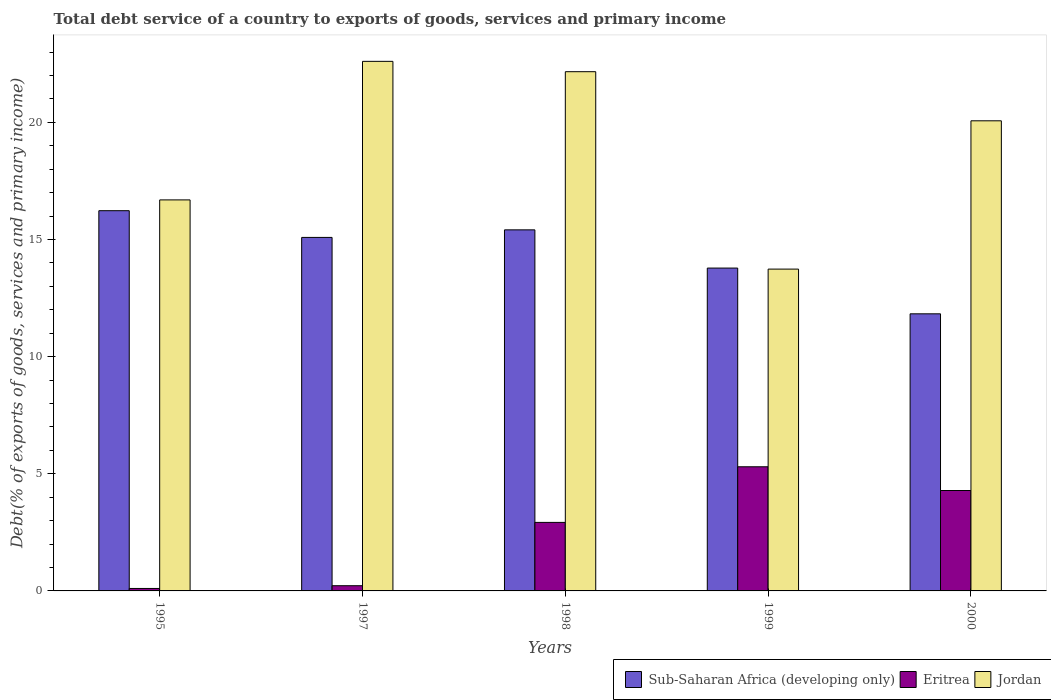How many different coloured bars are there?
Keep it short and to the point. 3. How many groups of bars are there?
Make the answer very short. 5. Are the number of bars per tick equal to the number of legend labels?
Make the answer very short. Yes. How many bars are there on the 5th tick from the left?
Give a very brief answer. 3. How many bars are there on the 2nd tick from the right?
Offer a terse response. 3. What is the label of the 4th group of bars from the left?
Make the answer very short. 1999. In how many cases, is the number of bars for a given year not equal to the number of legend labels?
Your response must be concise. 0. What is the total debt service in Jordan in 1997?
Keep it short and to the point. 22.6. Across all years, what is the maximum total debt service in Sub-Saharan Africa (developing only)?
Ensure brevity in your answer.  16.23. Across all years, what is the minimum total debt service in Sub-Saharan Africa (developing only)?
Give a very brief answer. 11.83. What is the total total debt service in Jordan in the graph?
Give a very brief answer. 95.25. What is the difference between the total debt service in Sub-Saharan Africa (developing only) in 1998 and that in 1999?
Give a very brief answer. 1.63. What is the difference between the total debt service in Eritrea in 2000 and the total debt service in Jordan in 1995?
Make the answer very short. -12.4. What is the average total debt service in Jordan per year?
Keep it short and to the point. 19.05. In the year 1998, what is the difference between the total debt service in Jordan and total debt service in Sub-Saharan Africa (developing only)?
Provide a short and direct response. 6.75. What is the ratio of the total debt service in Sub-Saharan Africa (developing only) in 1997 to that in 2000?
Make the answer very short. 1.28. Is the total debt service in Jordan in 1997 less than that in 2000?
Give a very brief answer. No. What is the difference between the highest and the second highest total debt service in Sub-Saharan Africa (developing only)?
Your response must be concise. 0.82. What is the difference between the highest and the lowest total debt service in Eritrea?
Your response must be concise. 5.19. What does the 1st bar from the left in 1995 represents?
Offer a very short reply. Sub-Saharan Africa (developing only). What does the 1st bar from the right in 1999 represents?
Your answer should be compact. Jordan. Is it the case that in every year, the sum of the total debt service in Eritrea and total debt service in Sub-Saharan Africa (developing only) is greater than the total debt service in Jordan?
Your response must be concise. No. How many years are there in the graph?
Your answer should be compact. 5. Are the values on the major ticks of Y-axis written in scientific E-notation?
Make the answer very short. No. How many legend labels are there?
Your answer should be compact. 3. How are the legend labels stacked?
Give a very brief answer. Horizontal. What is the title of the graph?
Give a very brief answer. Total debt service of a country to exports of goods, services and primary income. What is the label or title of the X-axis?
Provide a short and direct response. Years. What is the label or title of the Y-axis?
Provide a succinct answer. Debt(% of exports of goods, services and primary income). What is the Debt(% of exports of goods, services and primary income) of Sub-Saharan Africa (developing only) in 1995?
Offer a terse response. 16.23. What is the Debt(% of exports of goods, services and primary income) of Eritrea in 1995?
Provide a succinct answer. 0.11. What is the Debt(% of exports of goods, services and primary income) in Jordan in 1995?
Give a very brief answer. 16.69. What is the Debt(% of exports of goods, services and primary income) of Sub-Saharan Africa (developing only) in 1997?
Provide a short and direct response. 15.09. What is the Debt(% of exports of goods, services and primary income) of Eritrea in 1997?
Offer a terse response. 0.22. What is the Debt(% of exports of goods, services and primary income) of Jordan in 1997?
Ensure brevity in your answer.  22.6. What is the Debt(% of exports of goods, services and primary income) in Sub-Saharan Africa (developing only) in 1998?
Provide a succinct answer. 15.41. What is the Debt(% of exports of goods, services and primary income) in Eritrea in 1998?
Your response must be concise. 2.92. What is the Debt(% of exports of goods, services and primary income) of Jordan in 1998?
Offer a very short reply. 22.16. What is the Debt(% of exports of goods, services and primary income) in Sub-Saharan Africa (developing only) in 1999?
Your answer should be very brief. 13.78. What is the Debt(% of exports of goods, services and primary income) in Eritrea in 1999?
Your answer should be very brief. 5.3. What is the Debt(% of exports of goods, services and primary income) in Jordan in 1999?
Your answer should be compact. 13.74. What is the Debt(% of exports of goods, services and primary income) in Sub-Saharan Africa (developing only) in 2000?
Give a very brief answer. 11.83. What is the Debt(% of exports of goods, services and primary income) of Eritrea in 2000?
Your answer should be very brief. 4.29. What is the Debt(% of exports of goods, services and primary income) in Jordan in 2000?
Keep it short and to the point. 20.07. Across all years, what is the maximum Debt(% of exports of goods, services and primary income) in Sub-Saharan Africa (developing only)?
Make the answer very short. 16.23. Across all years, what is the maximum Debt(% of exports of goods, services and primary income) in Eritrea?
Your answer should be compact. 5.3. Across all years, what is the maximum Debt(% of exports of goods, services and primary income) in Jordan?
Give a very brief answer. 22.6. Across all years, what is the minimum Debt(% of exports of goods, services and primary income) in Sub-Saharan Africa (developing only)?
Your answer should be very brief. 11.83. Across all years, what is the minimum Debt(% of exports of goods, services and primary income) of Eritrea?
Ensure brevity in your answer.  0.11. Across all years, what is the minimum Debt(% of exports of goods, services and primary income) in Jordan?
Your response must be concise. 13.74. What is the total Debt(% of exports of goods, services and primary income) of Sub-Saharan Africa (developing only) in the graph?
Ensure brevity in your answer.  72.33. What is the total Debt(% of exports of goods, services and primary income) of Eritrea in the graph?
Provide a short and direct response. 12.84. What is the total Debt(% of exports of goods, services and primary income) in Jordan in the graph?
Keep it short and to the point. 95.25. What is the difference between the Debt(% of exports of goods, services and primary income) of Sub-Saharan Africa (developing only) in 1995 and that in 1997?
Provide a short and direct response. 1.14. What is the difference between the Debt(% of exports of goods, services and primary income) of Eritrea in 1995 and that in 1997?
Your response must be concise. -0.12. What is the difference between the Debt(% of exports of goods, services and primary income) of Jordan in 1995 and that in 1997?
Provide a short and direct response. -5.91. What is the difference between the Debt(% of exports of goods, services and primary income) of Sub-Saharan Africa (developing only) in 1995 and that in 1998?
Ensure brevity in your answer.  0.82. What is the difference between the Debt(% of exports of goods, services and primary income) of Eritrea in 1995 and that in 1998?
Give a very brief answer. -2.82. What is the difference between the Debt(% of exports of goods, services and primary income) of Jordan in 1995 and that in 1998?
Offer a very short reply. -5.47. What is the difference between the Debt(% of exports of goods, services and primary income) in Sub-Saharan Africa (developing only) in 1995 and that in 1999?
Your answer should be compact. 2.45. What is the difference between the Debt(% of exports of goods, services and primary income) of Eritrea in 1995 and that in 1999?
Your answer should be compact. -5.19. What is the difference between the Debt(% of exports of goods, services and primary income) in Jordan in 1995 and that in 1999?
Make the answer very short. 2.95. What is the difference between the Debt(% of exports of goods, services and primary income) in Sub-Saharan Africa (developing only) in 1995 and that in 2000?
Offer a terse response. 4.4. What is the difference between the Debt(% of exports of goods, services and primary income) of Eritrea in 1995 and that in 2000?
Ensure brevity in your answer.  -4.18. What is the difference between the Debt(% of exports of goods, services and primary income) in Jordan in 1995 and that in 2000?
Your answer should be compact. -3.38. What is the difference between the Debt(% of exports of goods, services and primary income) in Sub-Saharan Africa (developing only) in 1997 and that in 1998?
Your answer should be compact. -0.32. What is the difference between the Debt(% of exports of goods, services and primary income) of Eritrea in 1997 and that in 1998?
Provide a succinct answer. -2.7. What is the difference between the Debt(% of exports of goods, services and primary income) in Jordan in 1997 and that in 1998?
Give a very brief answer. 0.44. What is the difference between the Debt(% of exports of goods, services and primary income) in Sub-Saharan Africa (developing only) in 1997 and that in 1999?
Your answer should be compact. 1.31. What is the difference between the Debt(% of exports of goods, services and primary income) of Eritrea in 1997 and that in 1999?
Your answer should be compact. -5.08. What is the difference between the Debt(% of exports of goods, services and primary income) in Jordan in 1997 and that in 1999?
Your answer should be very brief. 8.87. What is the difference between the Debt(% of exports of goods, services and primary income) of Sub-Saharan Africa (developing only) in 1997 and that in 2000?
Make the answer very short. 3.26. What is the difference between the Debt(% of exports of goods, services and primary income) of Eritrea in 1997 and that in 2000?
Keep it short and to the point. -4.06. What is the difference between the Debt(% of exports of goods, services and primary income) of Jordan in 1997 and that in 2000?
Your answer should be compact. 2.54. What is the difference between the Debt(% of exports of goods, services and primary income) in Sub-Saharan Africa (developing only) in 1998 and that in 1999?
Make the answer very short. 1.63. What is the difference between the Debt(% of exports of goods, services and primary income) of Eritrea in 1998 and that in 1999?
Provide a short and direct response. -2.37. What is the difference between the Debt(% of exports of goods, services and primary income) of Jordan in 1998 and that in 1999?
Provide a succinct answer. 8.43. What is the difference between the Debt(% of exports of goods, services and primary income) in Sub-Saharan Africa (developing only) in 1998 and that in 2000?
Offer a terse response. 3.58. What is the difference between the Debt(% of exports of goods, services and primary income) in Eritrea in 1998 and that in 2000?
Make the answer very short. -1.36. What is the difference between the Debt(% of exports of goods, services and primary income) in Jordan in 1998 and that in 2000?
Keep it short and to the point. 2.1. What is the difference between the Debt(% of exports of goods, services and primary income) of Sub-Saharan Africa (developing only) in 1999 and that in 2000?
Your answer should be compact. 1.95. What is the difference between the Debt(% of exports of goods, services and primary income) in Eritrea in 1999 and that in 2000?
Your response must be concise. 1.01. What is the difference between the Debt(% of exports of goods, services and primary income) in Jordan in 1999 and that in 2000?
Ensure brevity in your answer.  -6.33. What is the difference between the Debt(% of exports of goods, services and primary income) of Sub-Saharan Africa (developing only) in 1995 and the Debt(% of exports of goods, services and primary income) of Eritrea in 1997?
Your response must be concise. 16.01. What is the difference between the Debt(% of exports of goods, services and primary income) in Sub-Saharan Africa (developing only) in 1995 and the Debt(% of exports of goods, services and primary income) in Jordan in 1997?
Give a very brief answer. -6.37. What is the difference between the Debt(% of exports of goods, services and primary income) of Eritrea in 1995 and the Debt(% of exports of goods, services and primary income) of Jordan in 1997?
Offer a very short reply. -22.5. What is the difference between the Debt(% of exports of goods, services and primary income) of Sub-Saharan Africa (developing only) in 1995 and the Debt(% of exports of goods, services and primary income) of Eritrea in 1998?
Provide a short and direct response. 13.3. What is the difference between the Debt(% of exports of goods, services and primary income) of Sub-Saharan Africa (developing only) in 1995 and the Debt(% of exports of goods, services and primary income) of Jordan in 1998?
Provide a succinct answer. -5.93. What is the difference between the Debt(% of exports of goods, services and primary income) of Eritrea in 1995 and the Debt(% of exports of goods, services and primary income) of Jordan in 1998?
Keep it short and to the point. -22.06. What is the difference between the Debt(% of exports of goods, services and primary income) of Sub-Saharan Africa (developing only) in 1995 and the Debt(% of exports of goods, services and primary income) of Eritrea in 1999?
Your answer should be compact. 10.93. What is the difference between the Debt(% of exports of goods, services and primary income) in Sub-Saharan Africa (developing only) in 1995 and the Debt(% of exports of goods, services and primary income) in Jordan in 1999?
Your answer should be very brief. 2.49. What is the difference between the Debt(% of exports of goods, services and primary income) of Eritrea in 1995 and the Debt(% of exports of goods, services and primary income) of Jordan in 1999?
Provide a succinct answer. -13.63. What is the difference between the Debt(% of exports of goods, services and primary income) in Sub-Saharan Africa (developing only) in 1995 and the Debt(% of exports of goods, services and primary income) in Eritrea in 2000?
Ensure brevity in your answer.  11.94. What is the difference between the Debt(% of exports of goods, services and primary income) in Sub-Saharan Africa (developing only) in 1995 and the Debt(% of exports of goods, services and primary income) in Jordan in 2000?
Your answer should be very brief. -3.84. What is the difference between the Debt(% of exports of goods, services and primary income) in Eritrea in 1995 and the Debt(% of exports of goods, services and primary income) in Jordan in 2000?
Your answer should be very brief. -19.96. What is the difference between the Debt(% of exports of goods, services and primary income) of Sub-Saharan Africa (developing only) in 1997 and the Debt(% of exports of goods, services and primary income) of Eritrea in 1998?
Provide a succinct answer. 12.16. What is the difference between the Debt(% of exports of goods, services and primary income) in Sub-Saharan Africa (developing only) in 1997 and the Debt(% of exports of goods, services and primary income) in Jordan in 1998?
Your answer should be compact. -7.07. What is the difference between the Debt(% of exports of goods, services and primary income) of Eritrea in 1997 and the Debt(% of exports of goods, services and primary income) of Jordan in 1998?
Your response must be concise. -21.94. What is the difference between the Debt(% of exports of goods, services and primary income) in Sub-Saharan Africa (developing only) in 1997 and the Debt(% of exports of goods, services and primary income) in Eritrea in 1999?
Your answer should be very brief. 9.79. What is the difference between the Debt(% of exports of goods, services and primary income) of Sub-Saharan Africa (developing only) in 1997 and the Debt(% of exports of goods, services and primary income) of Jordan in 1999?
Ensure brevity in your answer.  1.35. What is the difference between the Debt(% of exports of goods, services and primary income) of Eritrea in 1997 and the Debt(% of exports of goods, services and primary income) of Jordan in 1999?
Provide a short and direct response. -13.51. What is the difference between the Debt(% of exports of goods, services and primary income) in Sub-Saharan Africa (developing only) in 1997 and the Debt(% of exports of goods, services and primary income) in Eritrea in 2000?
Offer a terse response. 10.8. What is the difference between the Debt(% of exports of goods, services and primary income) in Sub-Saharan Africa (developing only) in 1997 and the Debt(% of exports of goods, services and primary income) in Jordan in 2000?
Ensure brevity in your answer.  -4.98. What is the difference between the Debt(% of exports of goods, services and primary income) in Eritrea in 1997 and the Debt(% of exports of goods, services and primary income) in Jordan in 2000?
Provide a short and direct response. -19.84. What is the difference between the Debt(% of exports of goods, services and primary income) of Sub-Saharan Africa (developing only) in 1998 and the Debt(% of exports of goods, services and primary income) of Eritrea in 1999?
Make the answer very short. 10.11. What is the difference between the Debt(% of exports of goods, services and primary income) of Sub-Saharan Africa (developing only) in 1998 and the Debt(% of exports of goods, services and primary income) of Jordan in 1999?
Keep it short and to the point. 1.68. What is the difference between the Debt(% of exports of goods, services and primary income) in Eritrea in 1998 and the Debt(% of exports of goods, services and primary income) in Jordan in 1999?
Ensure brevity in your answer.  -10.81. What is the difference between the Debt(% of exports of goods, services and primary income) of Sub-Saharan Africa (developing only) in 1998 and the Debt(% of exports of goods, services and primary income) of Eritrea in 2000?
Provide a succinct answer. 11.12. What is the difference between the Debt(% of exports of goods, services and primary income) of Sub-Saharan Africa (developing only) in 1998 and the Debt(% of exports of goods, services and primary income) of Jordan in 2000?
Offer a terse response. -4.65. What is the difference between the Debt(% of exports of goods, services and primary income) of Eritrea in 1998 and the Debt(% of exports of goods, services and primary income) of Jordan in 2000?
Your answer should be very brief. -17.14. What is the difference between the Debt(% of exports of goods, services and primary income) in Sub-Saharan Africa (developing only) in 1999 and the Debt(% of exports of goods, services and primary income) in Eritrea in 2000?
Ensure brevity in your answer.  9.49. What is the difference between the Debt(% of exports of goods, services and primary income) of Sub-Saharan Africa (developing only) in 1999 and the Debt(% of exports of goods, services and primary income) of Jordan in 2000?
Your answer should be compact. -6.29. What is the difference between the Debt(% of exports of goods, services and primary income) in Eritrea in 1999 and the Debt(% of exports of goods, services and primary income) in Jordan in 2000?
Keep it short and to the point. -14.77. What is the average Debt(% of exports of goods, services and primary income) in Sub-Saharan Africa (developing only) per year?
Your response must be concise. 14.47. What is the average Debt(% of exports of goods, services and primary income) in Eritrea per year?
Provide a succinct answer. 2.57. What is the average Debt(% of exports of goods, services and primary income) in Jordan per year?
Your answer should be very brief. 19.05. In the year 1995, what is the difference between the Debt(% of exports of goods, services and primary income) in Sub-Saharan Africa (developing only) and Debt(% of exports of goods, services and primary income) in Eritrea?
Offer a very short reply. 16.12. In the year 1995, what is the difference between the Debt(% of exports of goods, services and primary income) of Sub-Saharan Africa (developing only) and Debt(% of exports of goods, services and primary income) of Jordan?
Your answer should be very brief. -0.46. In the year 1995, what is the difference between the Debt(% of exports of goods, services and primary income) of Eritrea and Debt(% of exports of goods, services and primary income) of Jordan?
Your answer should be very brief. -16.58. In the year 1997, what is the difference between the Debt(% of exports of goods, services and primary income) in Sub-Saharan Africa (developing only) and Debt(% of exports of goods, services and primary income) in Eritrea?
Your answer should be very brief. 14.87. In the year 1997, what is the difference between the Debt(% of exports of goods, services and primary income) of Sub-Saharan Africa (developing only) and Debt(% of exports of goods, services and primary income) of Jordan?
Your answer should be compact. -7.51. In the year 1997, what is the difference between the Debt(% of exports of goods, services and primary income) in Eritrea and Debt(% of exports of goods, services and primary income) in Jordan?
Your answer should be very brief. -22.38. In the year 1998, what is the difference between the Debt(% of exports of goods, services and primary income) in Sub-Saharan Africa (developing only) and Debt(% of exports of goods, services and primary income) in Eritrea?
Provide a succinct answer. 12.49. In the year 1998, what is the difference between the Debt(% of exports of goods, services and primary income) in Sub-Saharan Africa (developing only) and Debt(% of exports of goods, services and primary income) in Jordan?
Your answer should be compact. -6.75. In the year 1998, what is the difference between the Debt(% of exports of goods, services and primary income) of Eritrea and Debt(% of exports of goods, services and primary income) of Jordan?
Make the answer very short. -19.24. In the year 1999, what is the difference between the Debt(% of exports of goods, services and primary income) in Sub-Saharan Africa (developing only) and Debt(% of exports of goods, services and primary income) in Eritrea?
Provide a short and direct response. 8.48. In the year 1999, what is the difference between the Debt(% of exports of goods, services and primary income) of Sub-Saharan Africa (developing only) and Debt(% of exports of goods, services and primary income) of Jordan?
Give a very brief answer. 0.04. In the year 1999, what is the difference between the Debt(% of exports of goods, services and primary income) in Eritrea and Debt(% of exports of goods, services and primary income) in Jordan?
Ensure brevity in your answer.  -8.44. In the year 2000, what is the difference between the Debt(% of exports of goods, services and primary income) in Sub-Saharan Africa (developing only) and Debt(% of exports of goods, services and primary income) in Eritrea?
Provide a succinct answer. 7.54. In the year 2000, what is the difference between the Debt(% of exports of goods, services and primary income) in Sub-Saharan Africa (developing only) and Debt(% of exports of goods, services and primary income) in Jordan?
Give a very brief answer. -8.24. In the year 2000, what is the difference between the Debt(% of exports of goods, services and primary income) in Eritrea and Debt(% of exports of goods, services and primary income) in Jordan?
Keep it short and to the point. -15.78. What is the ratio of the Debt(% of exports of goods, services and primary income) of Sub-Saharan Africa (developing only) in 1995 to that in 1997?
Make the answer very short. 1.08. What is the ratio of the Debt(% of exports of goods, services and primary income) in Eritrea in 1995 to that in 1997?
Offer a terse response. 0.47. What is the ratio of the Debt(% of exports of goods, services and primary income) of Jordan in 1995 to that in 1997?
Your answer should be compact. 0.74. What is the ratio of the Debt(% of exports of goods, services and primary income) in Sub-Saharan Africa (developing only) in 1995 to that in 1998?
Keep it short and to the point. 1.05. What is the ratio of the Debt(% of exports of goods, services and primary income) of Eritrea in 1995 to that in 1998?
Give a very brief answer. 0.04. What is the ratio of the Debt(% of exports of goods, services and primary income) in Jordan in 1995 to that in 1998?
Your response must be concise. 0.75. What is the ratio of the Debt(% of exports of goods, services and primary income) in Sub-Saharan Africa (developing only) in 1995 to that in 1999?
Your answer should be compact. 1.18. What is the ratio of the Debt(% of exports of goods, services and primary income) of Eritrea in 1995 to that in 1999?
Offer a terse response. 0.02. What is the ratio of the Debt(% of exports of goods, services and primary income) in Jordan in 1995 to that in 1999?
Keep it short and to the point. 1.22. What is the ratio of the Debt(% of exports of goods, services and primary income) in Sub-Saharan Africa (developing only) in 1995 to that in 2000?
Your answer should be very brief. 1.37. What is the ratio of the Debt(% of exports of goods, services and primary income) in Eritrea in 1995 to that in 2000?
Your answer should be very brief. 0.02. What is the ratio of the Debt(% of exports of goods, services and primary income) of Jordan in 1995 to that in 2000?
Your answer should be very brief. 0.83. What is the ratio of the Debt(% of exports of goods, services and primary income) in Sub-Saharan Africa (developing only) in 1997 to that in 1998?
Make the answer very short. 0.98. What is the ratio of the Debt(% of exports of goods, services and primary income) of Eritrea in 1997 to that in 1998?
Your response must be concise. 0.08. What is the ratio of the Debt(% of exports of goods, services and primary income) of Jordan in 1997 to that in 1998?
Provide a short and direct response. 1.02. What is the ratio of the Debt(% of exports of goods, services and primary income) of Sub-Saharan Africa (developing only) in 1997 to that in 1999?
Your answer should be compact. 1.09. What is the ratio of the Debt(% of exports of goods, services and primary income) in Eritrea in 1997 to that in 1999?
Offer a very short reply. 0.04. What is the ratio of the Debt(% of exports of goods, services and primary income) of Jordan in 1997 to that in 1999?
Your answer should be compact. 1.65. What is the ratio of the Debt(% of exports of goods, services and primary income) of Sub-Saharan Africa (developing only) in 1997 to that in 2000?
Ensure brevity in your answer.  1.28. What is the ratio of the Debt(% of exports of goods, services and primary income) of Eritrea in 1997 to that in 2000?
Give a very brief answer. 0.05. What is the ratio of the Debt(% of exports of goods, services and primary income) of Jordan in 1997 to that in 2000?
Ensure brevity in your answer.  1.13. What is the ratio of the Debt(% of exports of goods, services and primary income) of Sub-Saharan Africa (developing only) in 1998 to that in 1999?
Your answer should be very brief. 1.12. What is the ratio of the Debt(% of exports of goods, services and primary income) in Eritrea in 1998 to that in 1999?
Provide a succinct answer. 0.55. What is the ratio of the Debt(% of exports of goods, services and primary income) of Jordan in 1998 to that in 1999?
Your response must be concise. 1.61. What is the ratio of the Debt(% of exports of goods, services and primary income) of Sub-Saharan Africa (developing only) in 1998 to that in 2000?
Your response must be concise. 1.3. What is the ratio of the Debt(% of exports of goods, services and primary income) in Eritrea in 1998 to that in 2000?
Your answer should be compact. 0.68. What is the ratio of the Debt(% of exports of goods, services and primary income) in Jordan in 1998 to that in 2000?
Keep it short and to the point. 1.1. What is the ratio of the Debt(% of exports of goods, services and primary income) of Sub-Saharan Africa (developing only) in 1999 to that in 2000?
Your answer should be very brief. 1.17. What is the ratio of the Debt(% of exports of goods, services and primary income) of Eritrea in 1999 to that in 2000?
Give a very brief answer. 1.24. What is the ratio of the Debt(% of exports of goods, services and primary income) of Jordan in 1999 to that in 2000?
Offer a very short reply. 0.68. What is the difference between the highest and the second highest Debt(% of exports of goods, services and primary income) in Sub-Saharan Africa (developing only)?
Your response must be concise. 0.82. What is the difference between the highest and the second highest Debt(% of exports of goods, services and primary income) of Eritrea?
Offer a very short reply. 1.01. What is the difference between the highest and the second highest Debt(% of exports of goods, services and primary income) of Jordan?
Give a very brief answer. 0.44. What is the difference between the highest and the lowest Debt(% of exports of goods, services and primary income) of Sub-Saharan Africa (developing only)?
Provide a succinct answer. 4.4. What is the difference between the highest and the lowest Debt(% of exports of goods, services and primary income) in Eritrea?
Offer a terse response. 5.19. What is the difference between the highest and the lowest Debt(% of exports of goods, services and primary income) in Jordan?
Ensure brevity in your answer.  8.87. 